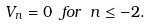<formula> <loc_0><loc_0><loc_500><loc_500>V _ { n } = 0 \ f o r \ n \leq - 2 .</formula> 